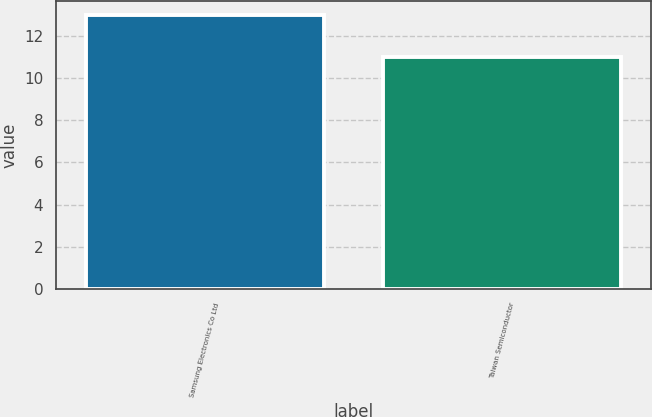Convert chart. <chart><loc_0><loc_0><loc_500><loc_500><bar_chart><fcel>Samsung Electronics Co Ltd<fcel>Taiwan Semiconductor<nl><fcel>13<fcel>11<nl></chart> 